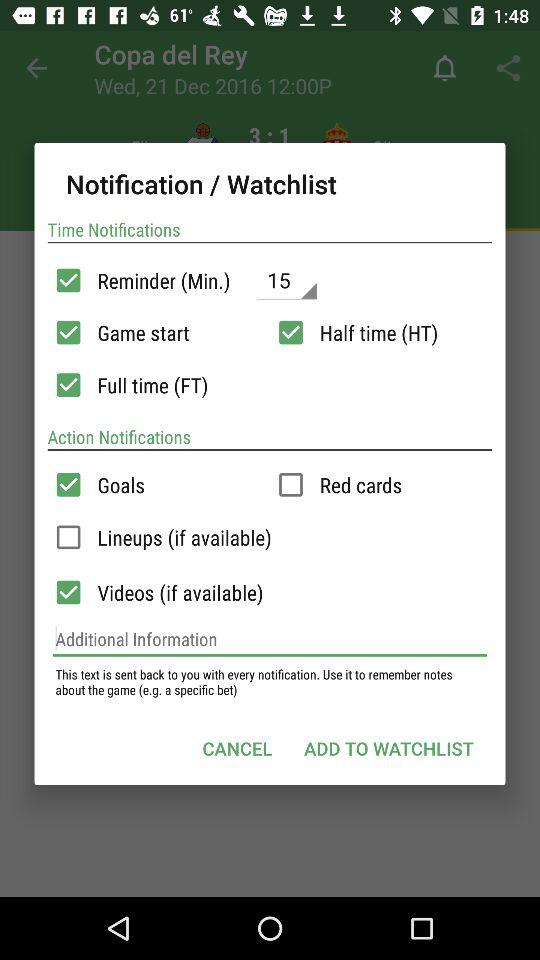What is the reminder time set in "Time Notifications"? The reminder time set in "Time Notifications" is 15 minutes. 